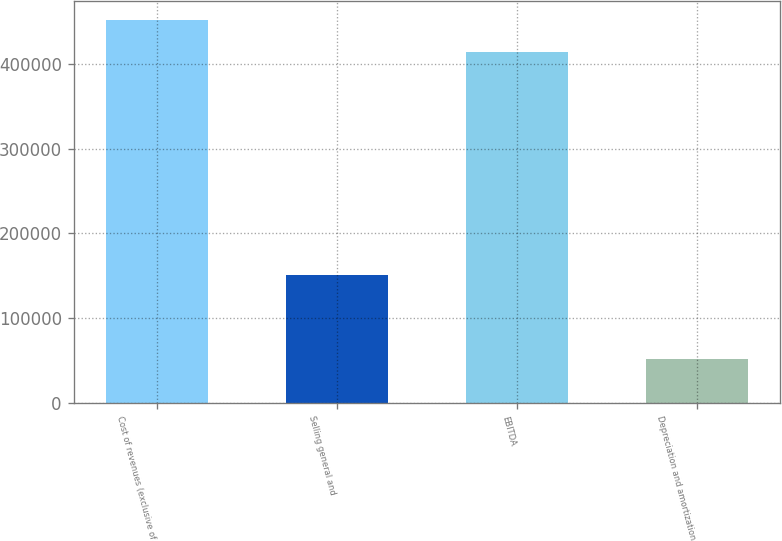Convert chart to OTSL. <chart><loc_0><loc_0><loc_500><loc_500><bar_chart><fcel>Cost of revenues (exclusive of<fcel>Selling general and<fcel>EBITDA<fcel>Depreciation and amortization<nl><fcel>450966<fcel>151557<fcel>413342<fcel>51739<nl></chart> 